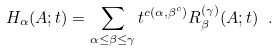Convert formula to latex. <formula><loc_0><loc_0><loc_500><loc_500>H _ { \alpha } ( A ; t ) = \sum _ { \alpha \leq \beta \leq \gamma } t ^ { c ( \alpha , \beta ^ { c } ) } R ^ { ( \gamma ) } _ { \beta } ( A ; t ) \ .</formula> 